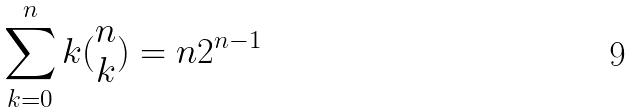<formula> <loc_0><loc_0><loc_500><loc_500>\sum _ { k = 0 } ^ { n } k ( \begin{matrix} n \\ k \end{matrix} ) = n 2 ^ { n - 1 }</formula> 